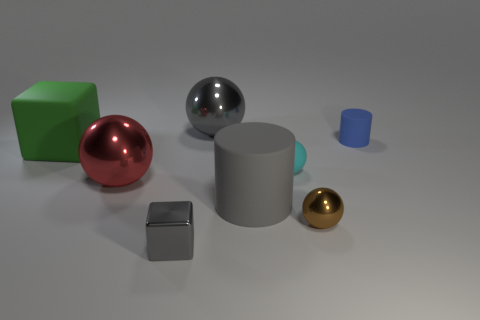There is a shiny block that is the same color as the large cylinder; what is its size?
Provide a succinct answer. Small. Is the shape of the small gray metallic object the same as the large green rubber thing?
Your answer should be very brief. Yes. How many things have the same material as the big cylinder?
Make the answer very short. 3. There is another matte thing that is the same shape as the red thing; what is its size?
Your answer should be very brief. Small. Do the gray cylinder and the red thing have the same size?
Make the answer very short. Yes. There is a big matte object behind the big rubber object that is to the right of the big shiny thing that is behind the tiny blue thing; what shape is it?
Offer a terse response. Cube. What is the color of the other matte object that is the same shape as the brown thing?
Your answer should be very brief. Cyan. There is a matte thing that is left of the cyan thing and behind the small cyan sphere; what is its size?
Offer a terse response. Large. What number of gray things are to the left of the gray shiny thing that is behind the cylinder that is in front of the red shiny ball?
Provide a short and direct response. 1. What number of small things are either brown shiny spheres or yellow rubber balls?
Provide a succinct answer. 1. 